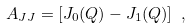Convert formula to latex. <formula><loc_0><loc_0><loc_500><loc_500>A _ { J J } = [ J _ { 0 } ( Q ) - J _ { 1 } ( Q ) ] \ ,</formula> 